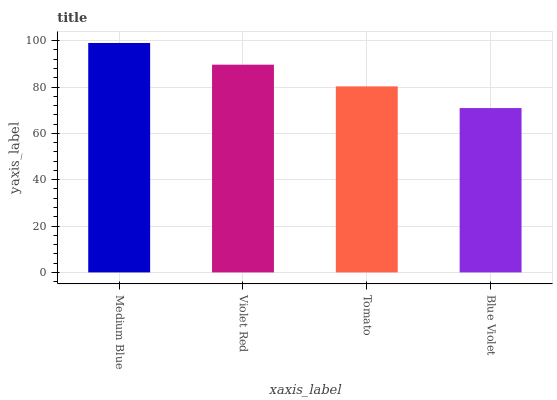Is Violet Red the minimum?
Answer yes or no. No. Is Violet Red the maximum?
Answer yes or no. No. Is Medium Blue greater than Violet Red?
Answer yes or no. Yes. Is Violet Red less than Medium Blue?
Answer yes or no. Yes. Is Violet Red greater than Medium Blue?
Answer yes or no. No. Is Medium Blue less than Violet Red?
Answer yes or no. No. Is Violet Red the high median?
Answer yes or no. Yes. Is Tomato the low median?
Answer yes or no. Yes. Is Blue Violet the high median?
Answer yes or no. No. Is Violet Red the low median?
Answer yes or no. No. 